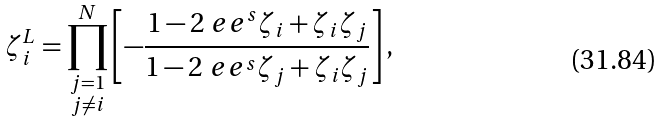<formula> <loc_0><loc_0><loc_500><loc_500>\zeta _ { i } ^ { L } = \prod _ { \substack { j = 1 \\ j \neq i } } ^ { N } \left [ - \frac { 1 - 2 \ e e ^ { s } \zeta _ { i } + \zeta _ { i } \zeta _ { j } } { 1 - 2 \ e e ^ { s } \zeta _ { j } + \zeta _ { i } \zeta _ { j } } \right ] ,</formula> 